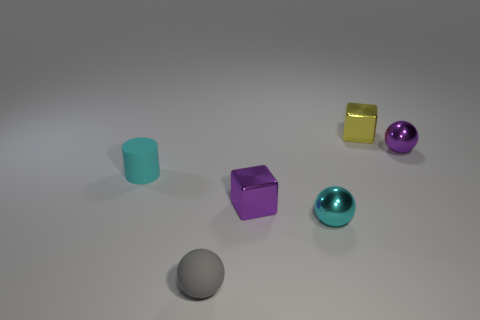Is there a consistent light source in this scene, and if so, what can we infer about it? Yes, the consistent shadowing beneath the objects suggests a single light source, possibly from above. The gentle shadows indicate a soft and diffused light, contributing to the serene ambiance of the scene.  Could you describe the texture surfaces of the objects? Certainly, the objects display a variety of textures: the cubes have a reflective, almost glass-like surface; the spheres show a metallic sheen; and the cylinder has a matte finish that scatters light differently, providing a compelling mix of surfaces. 